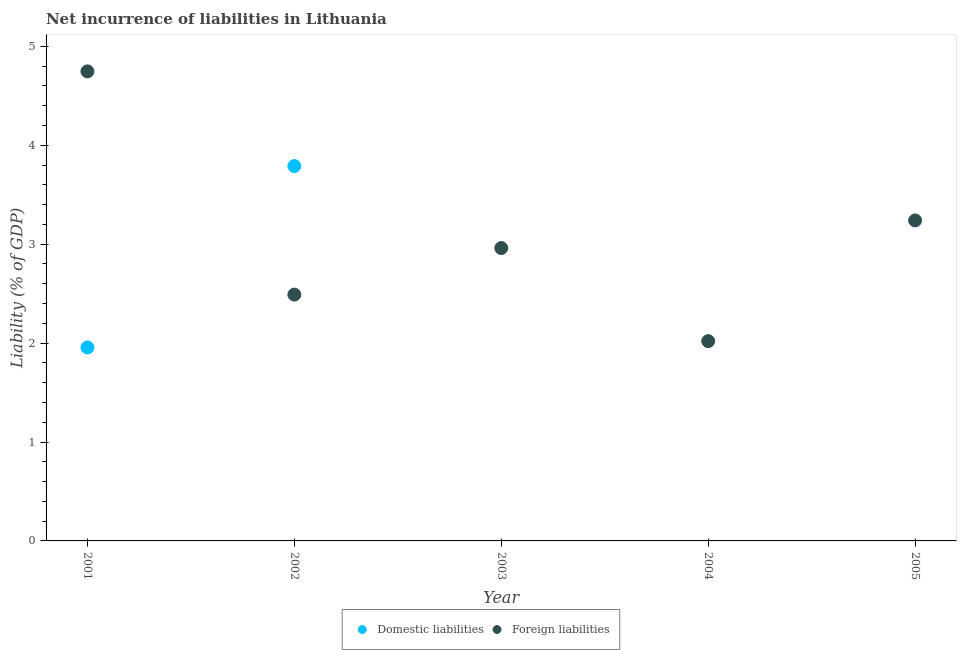How many different coloured dotlines are there?
Ensure brevity in your answer.  2. Is the number of dotlines equal to the number of legend labels?
Give a very brief answer. No. What is the incurrence of foreign liabilities in 2003?
Keep it short and to the point. 2.96. Across all years, what is the maximum incurrence of foreign liabilities?
Provide a short and direct response. 4.75. Across all years, what is the minimum incurrence of foreign liabilities?
Your answer should be compact. 2.02. In which year was the incurrence of domestic liabilities maximum?
Make the answer very short. 2002. What is the total incurrence of domestic liabilities in the graph?
Offer a terse response. 5.75. What is the difference between the incurrence of foreign liabilities in 2003 and that in 2004?
Make the answer very short. 0.94. What is the difference between the incurrence of domestic liabilities in 2002 and the incurrence of foreign liabilities in 2005?
Ensure brevity in your answer.  0.55. What is the average incurrence of foreign liabilities per year?
Ensure brevity in your answer.  3.09. In the year 2002, what is the difference between the incurrence of domestic liabilities and incurrence of foreign liabilities?
Offer a very short reply. 1.3. In how many years, is the incurrence of foreign liabilities greater than 2 %?
Your response must be concise. 5. What is the ratio of the incurrence of foreign liabilities in 2001 to that in 2002?
Provide a short and direct response. 1.91. Is the incurrence of foreign liabilities in 2001 less than that in 2003?
Provide a short and direct response. No. What is the difference between the highest and the second highest incurrence of foreign liabilities?
Offer a terse response. 1.51. What is the difference between the highest and the lowest incurrence of foreign liabilities?
Offer a very short reply. 2.73. Is the sum of the incurrence of domestic liabilities in 2001 and 2002 greater than the maximum incurrence of foreign liabilities across all years?
Offer a terse response. Yes. Is the incurrence of foreign liabilities strictly less than the incurrence of domestic liabilities over the years?
Offer a terse response. No. How many dotlines are there?
Your response must be concise. 2. Does the graph contain any zero values?
Give a very brief answer. Yes. How many legend labels are there?
Make the answer very short. 2. How are the legend labels stacked?
Give a very brief answer. Horizontal. What is the title of the graph?
Make the answer very short. Net incurrence of liabilities in Lithuania. What is the label or title of the X-axis?
Provide a succinct answer. Year. What is the label or title of the Y-axis?
Provide a short and direct response. Liability (% of GDP). What is the Liability (% of GDP) in Domestic liabilities in 2001?
Provide a succinct answer. 1.96. What is the Liability (% of GDP) in Foreign liabilities in 2001?
Provide a succinct answer. 4.75. What is the Liability (% of GDP) of Domestic liabilities in 2002?
Make the answer very short. 3.79. What is the Liability (% of GDP) in Foreign liabilities in 2002?
Offer a terse response. 2.49. What is the Liability (% of GDP) in Foreign liabilities in 2003?
Your answer should be very brief. 2.96. What is the Liability (% of GDP) in Domestic liabilities in 2004?
Provide a succinct answer. 0. What is the Liability (% of GDP) of Foreign liabilities in 2004?
Your answer should be compact. 2.02. What is the Liability (% of GDP) in Foreign liabilities in 2005?
Your answer should be compact. 3.24. Across all years, what is the maximum Liability (% of GDP) in Domestic liabilities?
Make the answer very short. 3.79. Across all years, what is the maximum Liability (% of GDP) of Foreign liabilities?
Offer a terse response. 4.75. Across all years, what is the minimum Liability (% of GDP) in Domestic liabilities?
Offer a terse response. 0. Across all years, what is the minimum Liability (% of GDP) of Foreign liabilities?
Offer a terse response. 2.02. What is the total Liability (% of GDP) of Domestic liabilities in the graph?
Keep it short and to the point. 5.75. What is the total Liability (% of GDP) of Foreign liabilities in the graph?
Offer a very short reply. 15.46. What is the difference between the Liability (% of GDP) in Domestic liabilities in 2001 and that in 2002?
Your answer should be compact. -1.83. What is the difference between the Liability (% of GDP) of Foreign liabilities in 2001 and that in 2002?
Ensure brevity in your answer.  2.26. What is the difference between the Liability (% of GDP) of Foreign liabilities in 2001 and that in 2003?
Offer a very short reply. 1.79. What is the difference between the Liability (% of GDP) in Foreign liabilities in 2001 and that in 2004?
Provide a short and direct response. 2.73. What is the difference between the Liability (% of GDP) of Foreign liabilities in 2001 and that in 2005?
Keep it short and to the point. 1.51. What is the difference between the Liability (% of GDP) in Foreign liabilities in 2002 and that in 2003?
Your response must be concise. -0.47. What is the difference between the Liability (% of GDP) of Foreign liabilities in 2002 and that in 2004?
Ensure brevity in your answer.  0.47. What is the difference between the Liability (% of GDP) in Foreign liabilities in 2002 and that in 2005?
Provide a succinct answer. -0.75. What is the difference between the Liability (% of GDP) of Foreign liabilities in 2003 and that in 2004?
Make the answer very short. 0.94. What is the difference between the Liability (% of GDP) of Foreign liabilities in 2003 and that in 2005?
Offer a very short reply. -0.28. What is the difference between the Liability (% of GDP) in Foreign liabilities in 2004 and that in 2005?
Your response must be concise. -1.22. What is the difference between the Liability (% of GDP) in Domestic liabilities in 2001 and the Liability (% of GDP) in Foreign liabilities in 2002?
Offer a terse response. -0.53. What is the difference between the Liability (% of GDP) of Domestic liabilities in 2001 and the Liability (% of GDP) of Foreign liabilities in 2003?
Your response must be concise. -1. What is the difference between the Liability (% of GDP) in Domestic liabilities in 2001 and the Liability (% of GDP) in Foreign liabilities in 2004?
Make the answer very short. -0.06. What is the difference between the Liability (% of GDP) in Domestic liabilities in 2001 and the Liability (% of GDP) in Foreign liabilities in 2005?
Your answer should be compact. -1.28. What is the difference between the Liability (% of GDP) in Domestic liabilities in 2002 and the Liability (% of GDP) in Foreign liabilities in 2003?
Keep it short and to the point. 0.83. What is the difference between the Liability (% of GDP) of Domestic liabilities in 2002 and the Liability (% of GDP) of Foreign liabilities in 2004?
Provide a short and direct response. 1.77. What is the difference between the Liability (% of GDP) of Domestic liabilities in 2002 and the Liability (% of GDP) of Foreign liabilities in 2005?
Keep it short and to the point. 0.55. What is the average Liability (% of GDP) of Domestic liabilities per year?
Your answer should be very brief. 1.15. What is the average Liability (% of GDP) of Foreign liabilities per year?
Ensure brevity in your answer.  3.09. In the year 2001, what is the difference between the Liability (% of GDP) of Domestic liabilities and Liability (% of GDP) of Foreign liabilities?
Give a very brief answer. -2.79. In the year 2002, what is the difference between the Liability (% of GDP) in Domestic liabilities and Liability (% of GDP) in Foreign liabilities?
Make the answer very short. 1.3. What is the ratio of the Liability (% of GDP) in Domestic liabilities in 2001 to that in 2002?
Give a very brief answer. 0.52. What is the ratio of the Liability (% of GDP) in Foreign liabilities in 2001 to that in 2002?
Make the answer very short. 1.91. What is the ratio of the Liability (% of GDP) of Foreign liabilities in 2001 to that in 2003?
Offer a terse response. 1.6. What is the ratio of the Liability (% of GDP) in Foreign liabilities in 2001 to that in 2004?
Offer a very short reply. 2.35. What is the ratio of the Liability (% of GDP) in Foreign liabilities in 2001 to that in 2005?
Your answer should be very brief. 1.47. What is the ratio of the Liability (% of GDP) in Foreign liabilities in 2002 to that in 2003?
Your answer should be very brief. 0.84. What is the ratio of the Liability (% of GDP) of Foreign liabilities in 2002 to that in 2004?
Offer a very short reply. 1.23. What is the ratio of the Liability (% of GDP) of Foreign liabilities in 2002 to that in 2005?
Give a very brief answer. 0.77. What is the ratio of the Liability (% of GDP) of Foreign liabilities in 2003 to that in 2004?
Make the answer very short. 1.47. What is the ratio of the Liability (% of GDP) of Foreign liabilities in 2003 to that in 2005?
Your response must be concise. 0.91. What is the ratio of the Liability (% of GDP) in Foreign liabilities in 2004 to that in 2005?
Your answer should be very brief. 0.62. What is the difference between the highest and the second highest Liability (% of GDP) in Foreign liabilities?
Make the answer very short. 1.51. What is the difference between the highest and the lowest Liability (% of GDP) in Domestic liabilities?
Your response must be concise. 3.79. What is the difference between the highest and the lowest Liability (% of GDP) in Foreign liabilities?
Your answer should be compact. 2.73. 